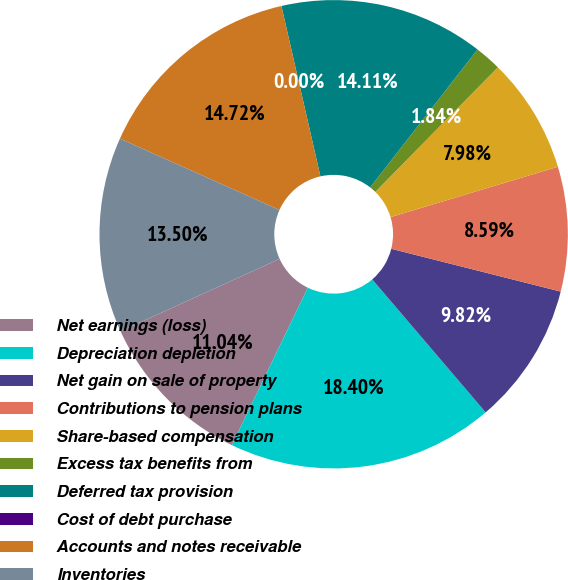<chart> <loc_0><loc_0><loc_500><loc_500><pie_chart><fcel>Net earnings (loss)<fcel>Depreciation depletion<fcel>Net gain on sale of property<fcel>Contributions to pension plans<fcel>Share-based compensation<fcel>Excess tax benefits from<fcel>Deferred tax provision<fcel>Cost of debt purchase<fcel>Accounts and notes receivable<fcel>Inventories<nl><fcel>11.04%<fcel>18.4%<fcel>9.82%<fcel>8.59%<fcel>7.98%<fcel>1.84%<fcel>14.11%<fcel>0.0%<fcel>14.72%<fcel>13.5%<nl></chart> 